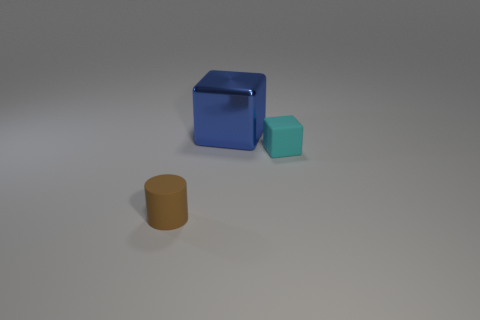Do the brown thing and the metal object that is on the right side of the cylinder have the same size?
Make the answer very short. No. There is a cube that is in front of the large object that is to the right of the tiny thing that is in front of the cyan rubber cube; what is its size?
Offer a very short reply. Small. Is there a rubber object?
Your response must be concise. Yes. What number of metallic blocks are the same color as the small cylinder?
Ensure brevity in your answer.  0. How many objects are objects that are in front of the cyan matte block or blocks in front of the shiny block?
Offer a very short reply. 2. How many small brown matte cylinders are in front of the tiny matte thing to the right of the big metallic object?
Make the answer very short. 1. The tiny object that is the same material as the brown cylinder is what color?
Provide a short and direct response. Cyan. Are there any blue cylinders of the same size as the cyan rubber cube?
Provide a short and direct response. No. There is a matte thing that is the same size as the cyan cube; what is its shape?
Provide a short and direct response. Cylinder. Is there a tiny cyan thing of the same shape as the big metal thing?
Provide a short and direct response. Yes. 